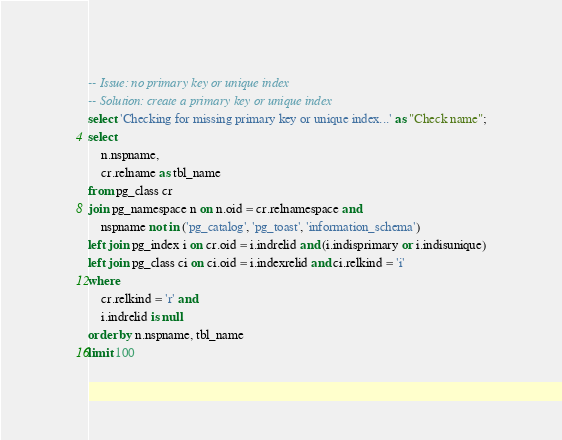Convert code to text. <code><loc_0><loc_0><loc_500><loc_500><_SQL_>-- Issue: no primary key or unique index
-- Solution: create a primary key or unique index
select 'Checking for missing primary key or unique index...' as "Check name";
select
	n.nspname,
	cr.relname as tbl_name
from pg_class cr
join pg_namespace n on n.oid = cr.relnamespace and
	nspname not in ('pg_catalog', 'pg_toast', 'information_schema')
left join pg_index i on cr.oid = i.indrelid and (i.indisprimary or i.indisunique)
left join pg_class ci on ci.oid = i.indexrelid and ci.relkind = 'i'  
where
	cr.relkind = 'r' and
	i.indrelid is null
order by n.nspname, tbl_name
limit 100</code> 